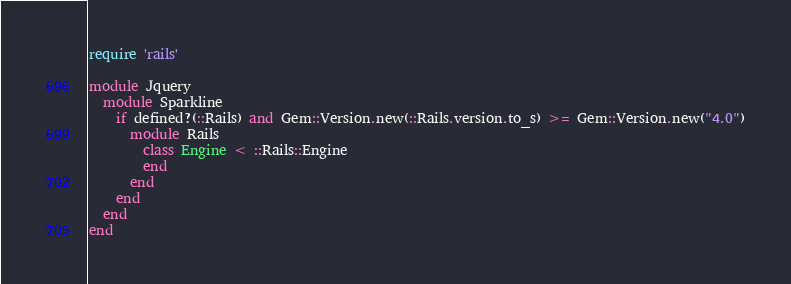Convert code to text. <code><loc_0><loc_0><loc_500><loc_500><_Ruby_>require 'rails'

module Jquery
  module Sparkline
    if defined?(::Rails) and Gem::Version.new(::Rails.version.to_s) >= Gem::Version.new("4.0")
      module Rails
        class Engine < ::Rails::Engine
        end
      end
    end
  end
end
</code> 